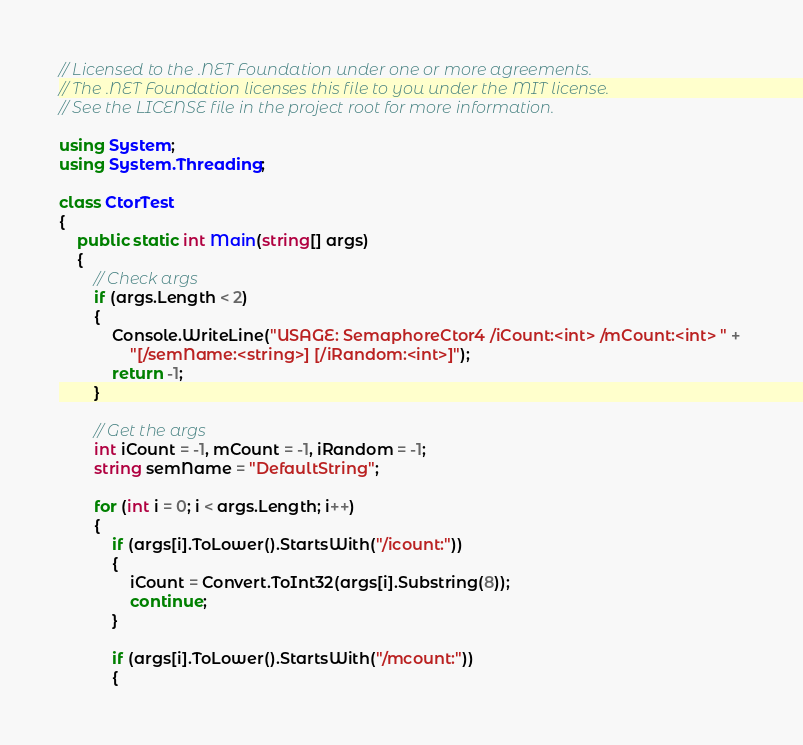Convert code to text. <code><loc_0><loc_0><loc_500><loc_500><_C#_>// Licensed to the .NET Foundation under one or more agreements.
// The .NET Foundation licenses this file to you under the MIT license.
// See the LICENSE file in the project root for more information.

using System;
using System.Threading;

class CtorTest
{
    public static int Main(string[] args)
    {
        // Check args
        if (args.Length < 2)
        {
            Console.WriteLine("USAGE: SemaphoreCtor4 /iCount:<int> /mCount:<int> " + 
                "[/semName:<string>] [/iRandom:<int>]");
            return -1;
        }

        // Get the args
        int iCount = -1, mCount = -1, iRandom = -1;
        string semName = "DefaultString";

        for (int i = 0; i < args.Length; i++)
        {
            if (args[i].ToLower().StartsWith("/icount:"))
            {
                iCount = Convert.ToInt32(args[i].Substring(8));
                continue;
            }

            if (args[i].ToLower().StartsWith("/mcount:"))
            {</code> 